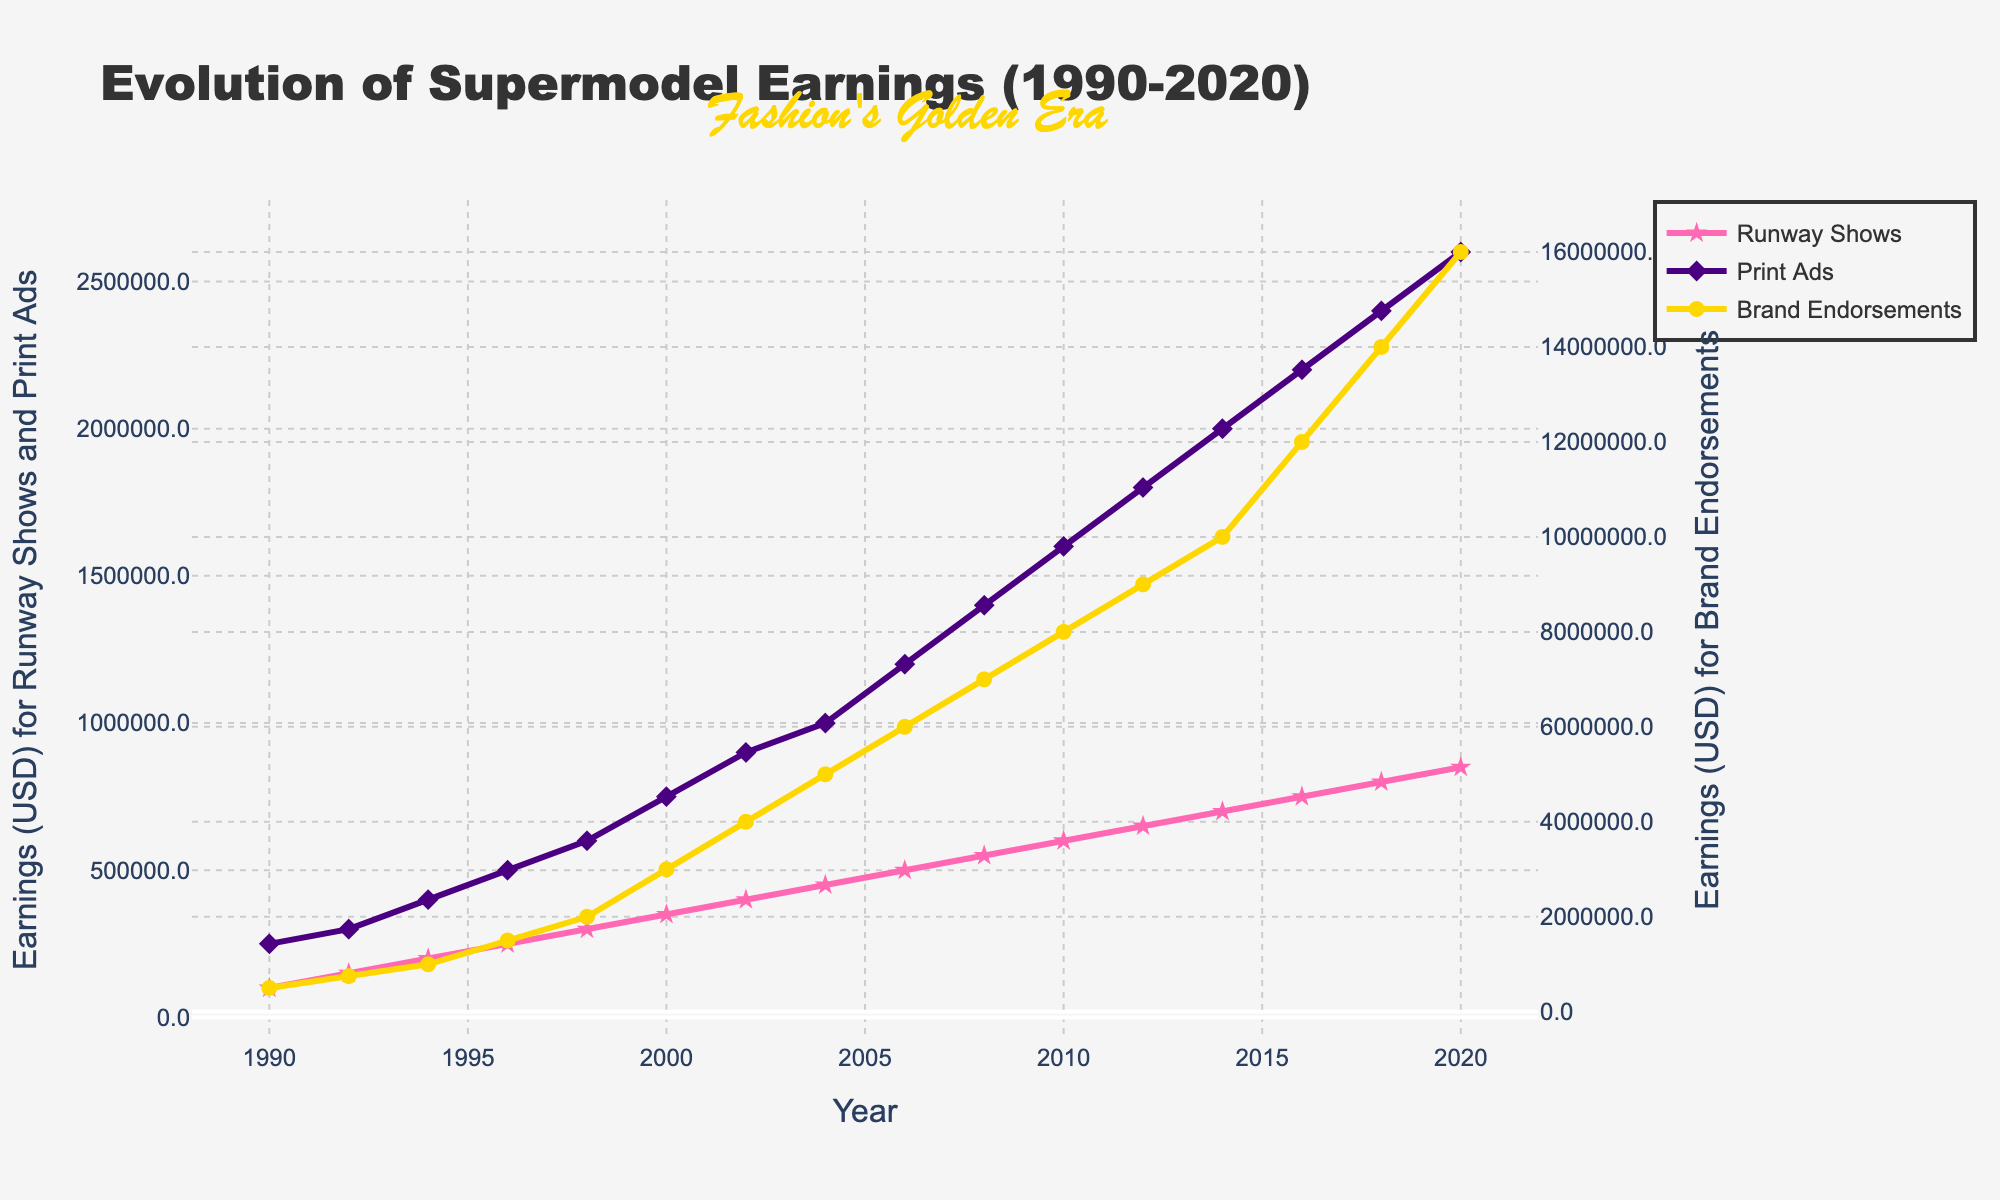What year did Runway Shows earnings first go above 500,000 USD? The graph shows the earnings for Runway Shows in pink. By observing the plot, the earnings first exceed 500,000 USD in the year 2006.
Answer: 2006 Which type of earnings had the highest increase from 1990 to 2020? The highest increase can be identified by looking at the endpoints of each line. Brand Endorsements, indicated in yellow, increase from 500,000 USD in 1990 to 16,000,000 USD in 2020, which is the highest increase.
Answer: Brand Endorsements Between 2000 and 2010, which type of earnings had the most consistent growth? Consistent growth can be identified by looking at the smoothness and regularity of the line increments. Print Ads, indicated in purple, show the most consistent upward trend without major fluctuations during this period.
Answer: Print Ads In 2012, how much more were earnings from Brand Endorsements compared to Runway Shows? Find the values of Brand Endorsements and Runway Shows in 2012. Brand Endorsements were 9,000,000 USD, and Runway Shows were 650,000 USD. The difference is 9,000,000 - 650,000 = 8,350,000 USD.
Answer: 8,350,000 USD By how much did Print Ads earnings increase from 1994 to 1998? Look for the values in the years 1994 and 1998 for Print Ads. In 1994, the earnings were 400,000 USD, and in 1998, they were 600,000 USD. The increase is 600,000 - 400,000 = 200,000 USD.
Answer: 200,000 USD What is the average yearly earnings from Runway Shows between 2010 and 2020? Sum the values of Runway Shows from 2010 to 2020, and divide by the number of years. Sum = 600,000 + 650,000 + 700,000 + 750,000 + 800,000 + 850,000 = 4,350,000. Average = 4,350,000 / 6 = 725,000 USD.
Answer: 725,000 USD Which earnings category reached 1,000,000 USD first and in what year? Identify the earliest year each category hits 1,000,000 USD by looking for their corresponding lines. Brand Endorsements reached 1,000,000 USD first in 1994.
Answer: Brand Endorsements in 1994 What can be said about the growth trend of Runway Shows from 1996 to 2004? Observing the pink line from 1996 to 2004, it shows a steady and consistent upward trend, indicating continuous growth each year.
Answer: Steady and consistent growth 